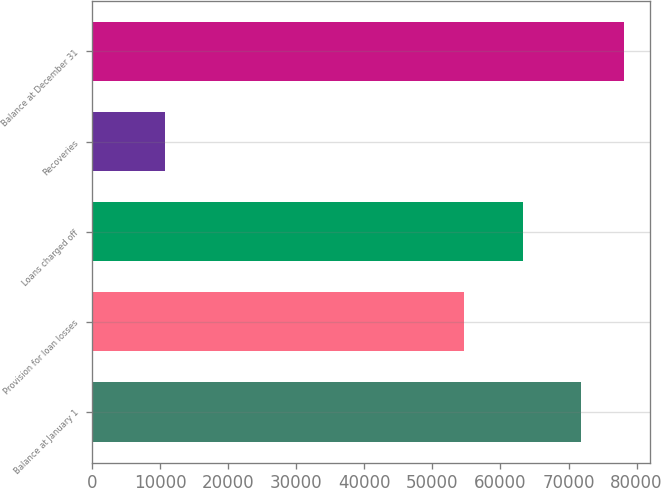Convert chart to OTSL. <chart><loc_0><loc_0><loc_500><loc_500><bar_chart><fcel>Balance at January 1<fcel>Provision for loan losses<fcel>Loans charged off<fcel>Recoveries<fcel>Balance at December 31<nl><fcel>71800<fcel>54602<fcel>63380<fcel>10778<fcel>78102.2<nl></chart> 